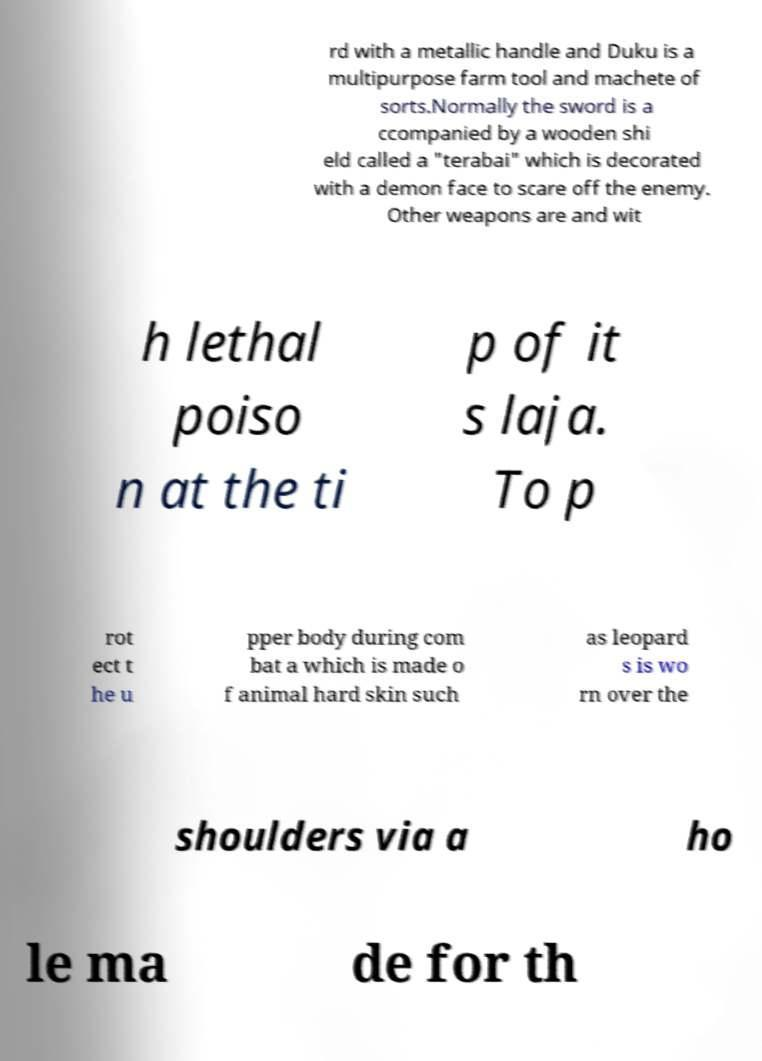Please read and relay the text visible in this image. What does it say? rd with a metallic handle and Duku is a multipurpose farm tool and machete of sorts.Normally the sword is a ccompanied by a wooden shi eld called a "terabai" which is decorated with a demon face to scare off the enemy. Other weapons are and wit h lethal poiso n at the ti p of it s laja. To p rot ect t he u pper body during com bat a which is made o f animal hard skin such as leopard s is wo rn over the shoulders via a ho le ma de for th 